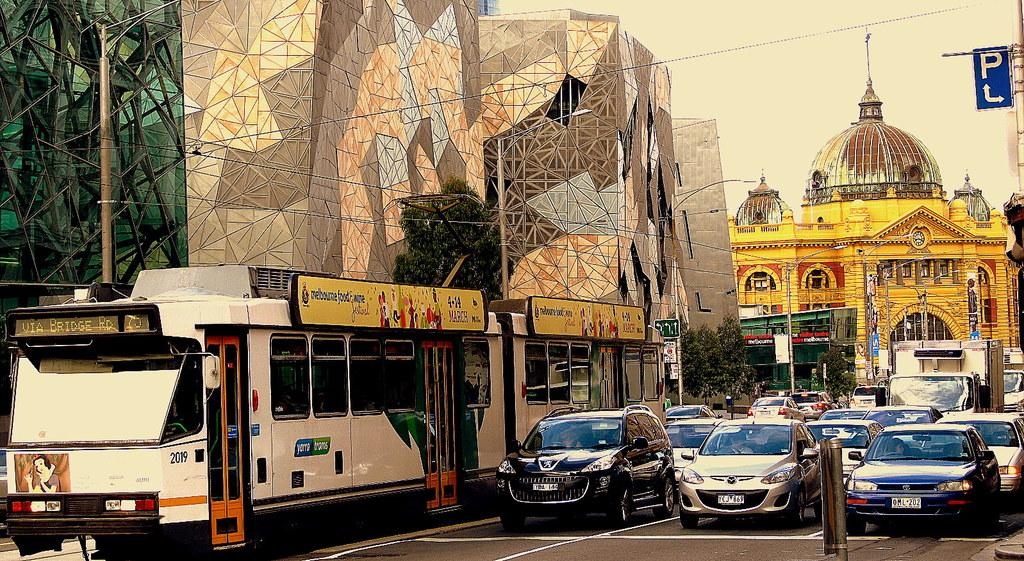<image>
Describe the image concisely. An advertisement on a bus promotes the Melbourne Food & Wine Festival. 